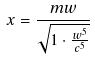<formula> <loc_0><loc_0><loc_500><loc_500>x = \frac { m w } { \sqrt { 1 \cdot \frac { w ^ { 5 } } { c ^ { 5 } } } }</formula> 